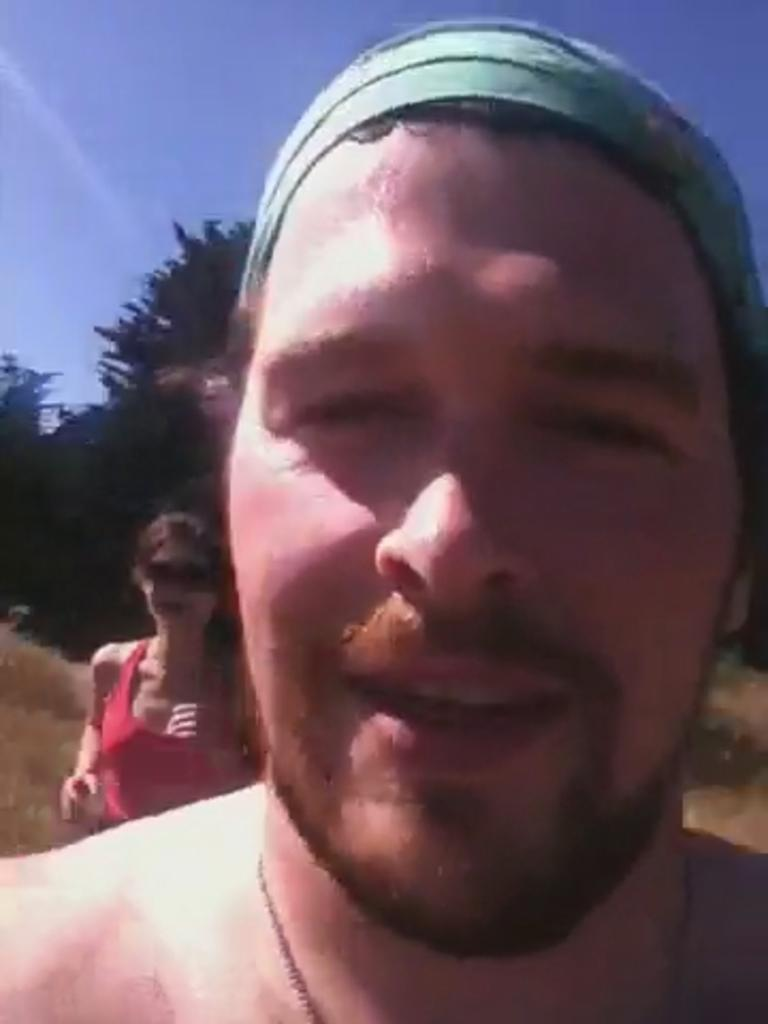Who is the main subject in the image? There is a man in the image. Can you describe the background of the image? There are trees and the sky visible in the background of the image. Are there any other people in the image besides the man? Yes, there is a lady in the background of the image. Reasoning: Let's think step by breaking down the conversation step by step. We start by identifying the main subject in the image, which is the man. Then, we describe the background of the image, which includes trees and the sky. Finally, we mention the presence of the lady in the background, which adds more detail to the scene. Absurd Question/Answer: What type of rail can be seen in the man's pocket in the image? There is no rail present in the image, nor is there any indication that the man has a rail in his pocket. 